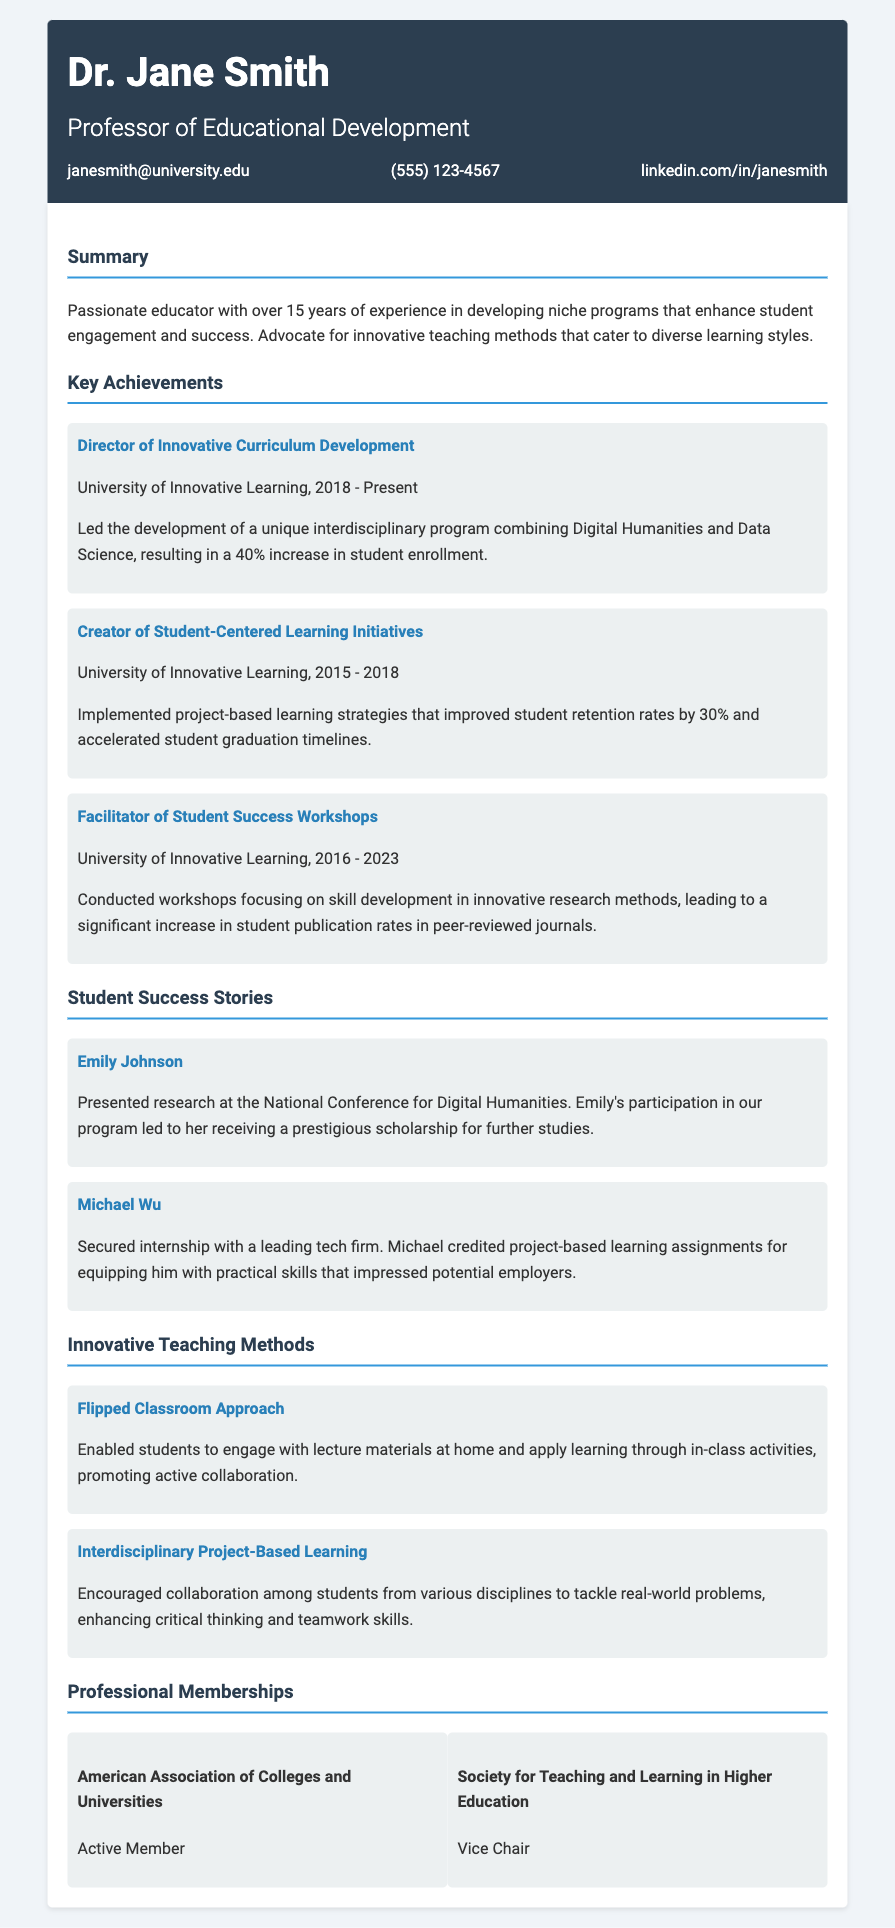what is the name of the professor? The name of the professor is listed prominently at the top of the document in the header section.
Answer: Dr. Jane Smith which program did Dr. Jane Smith lead the development of? The program mentioned in the key achievements section is the unique interdisciplinary program that combines Digital Humanities and Data Science.
Answer: Digital Humanities and Data Science how much did student enrollment increase by this program? The document quantifies the increase in student enrollment due to the program development.
Answer: 40% what did Emily Johnson achieve? The success stories highlight significant achievements of students, and Emily's achievement is mentioned specifically.
Answer: Presented research at the National Conference for Digital Humanities what teaching method promotes active collaboration? The teaching method section mentions a specific approach that allows for engagement at home and collaboration in class.
Answer: Flipped Classroom Approach how many years of experience does Dr. Jane Smith have? The summary section provides an overview of Dr. Jane Smith's experience in years.
Answer: Over 15 years which organization does Dr. Jane Smith serve as Vice Chair? The professional memberships section lists the organizations she is a part of, including her role.
Answer: Society for Teaching and Learning in Higher Education what was the increase in student retention rates? The achievements section provides a specific percentage of improvement in student retention rates related to initiatives implemented.
Answer: 30% what skill development focus did student success workshops emphasize? The document mentions the workshop's focus on a particular skill development aspect that led to increased publication rates.
Answer: Innovative research methods 